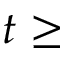Convert formula to latex. <formula><loc_0><loc_0><loc_500><loc_500>t \geq</formula> 